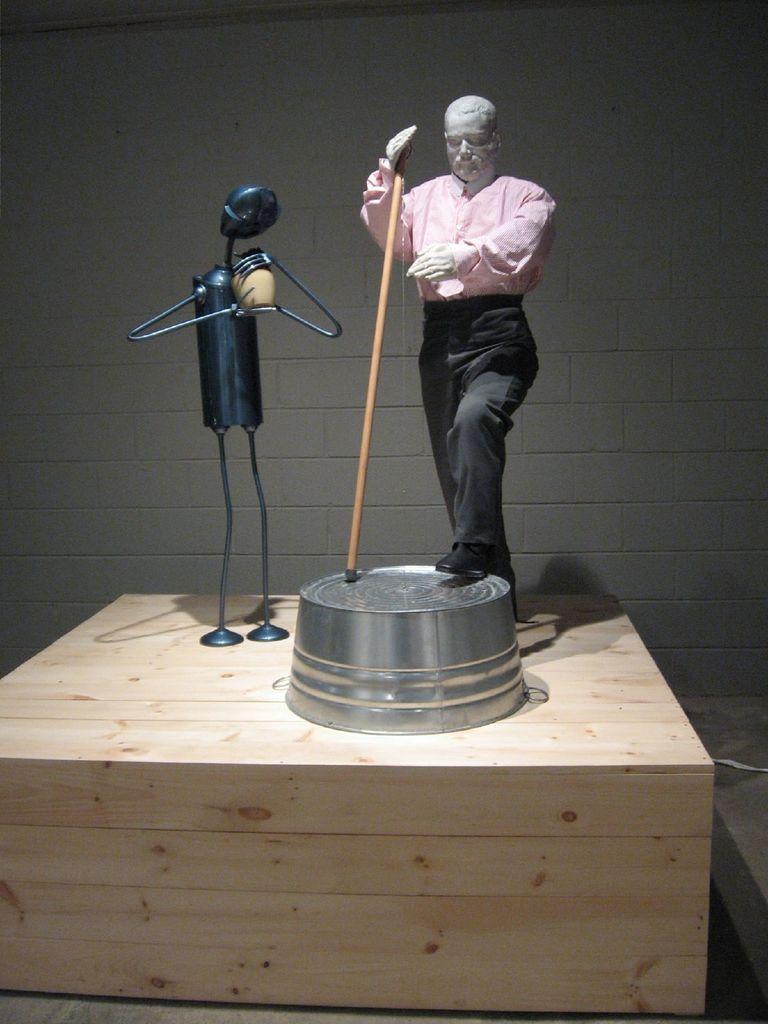Describe this image in one or two sentences. In this image, we can see show pieces on the wooden block. Here we can see the surface. In the background, there is a wall. 